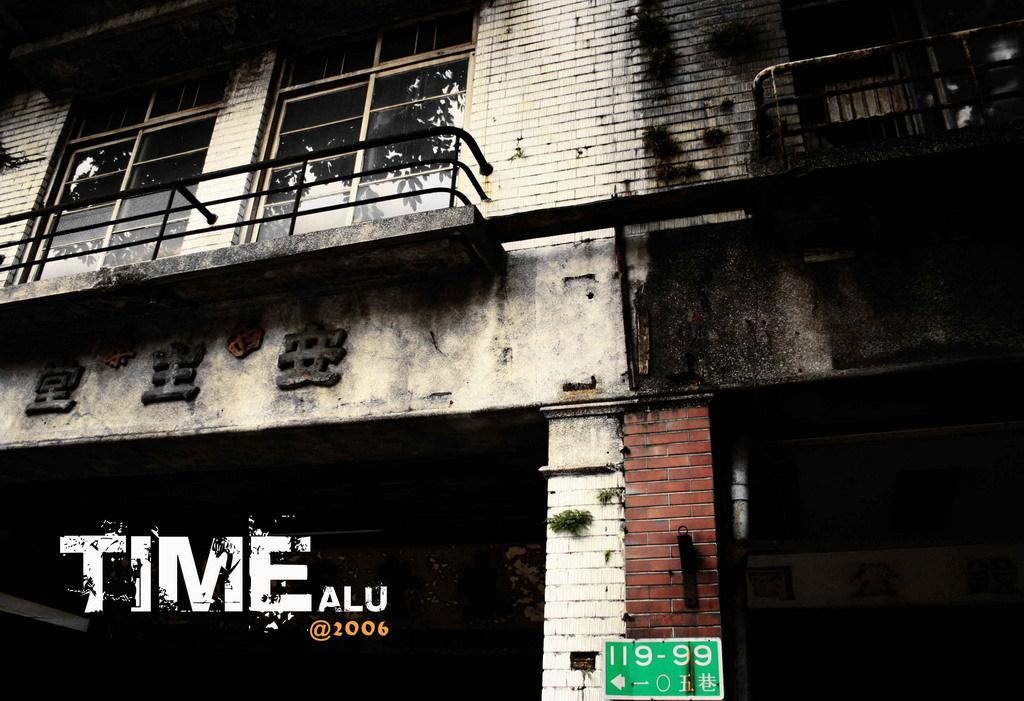What type of structure is present in the image? There is a building in the image. What else can be seen on the building or near it? There is a board with text in the image. Can you read any text in the image? Yes, there is text visible at the bottom left corner of the image. How many bikes are parked in front of the building in the image? There is no information about bikes in the image, so we cannot determine how many are present. 